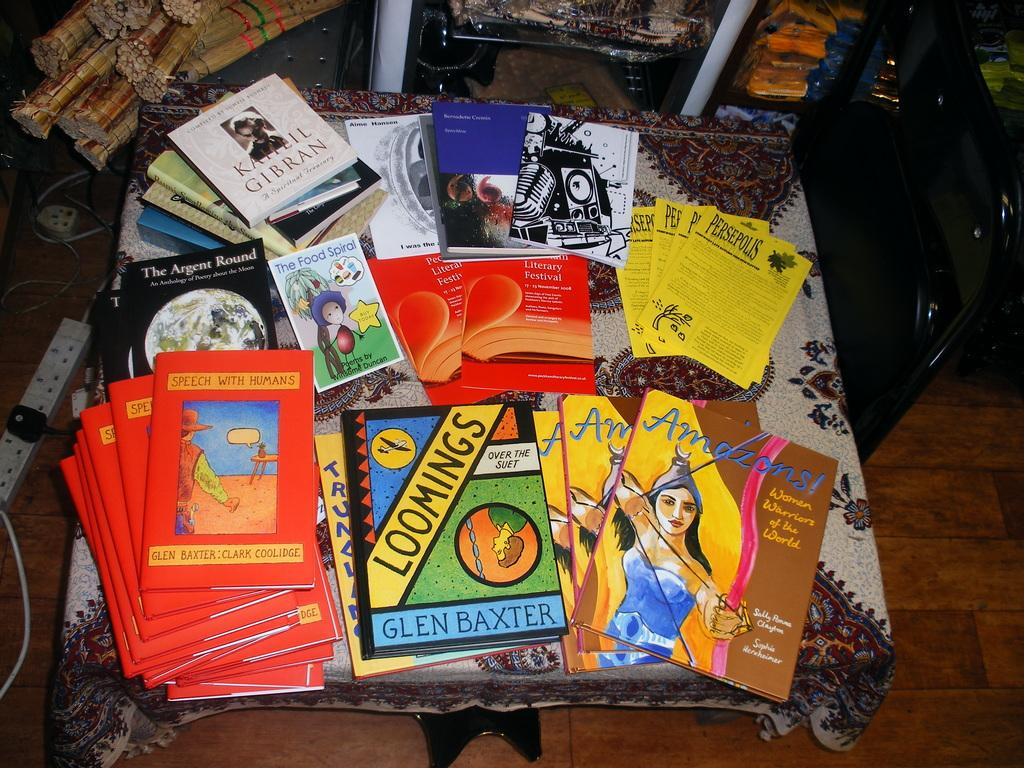<image>
Provide a brief description of the given image. A book titled Loomings sits on a pile with other books. 